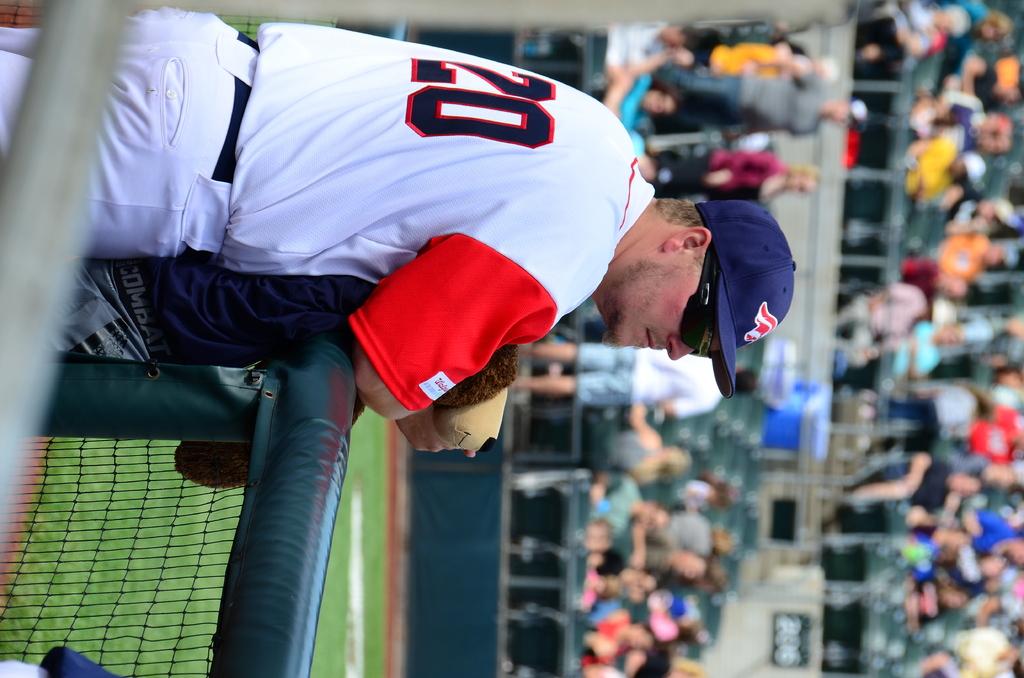What number is on his jersey?
Offer a terse response. 20. 